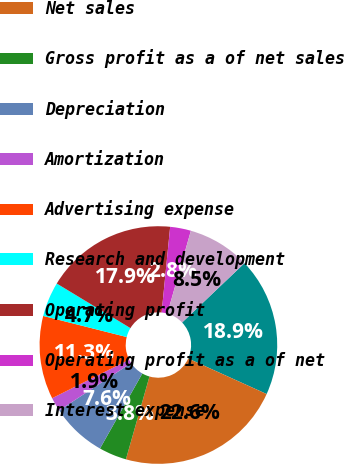Convert chart. <chart><loc_0><loc_0><loc_500><loc_500><pie_chart><fcel>(in millions except per share<fcel>Net sales<fcel>Gross profit as a of net sales<fcel>Depreciation<fcel>Amortization<fcel>Advertising expense<fcel>Research and development<fcel>Operating profit<fcel>Operating profit as a of net<fcel>Interest expense<nl><fcel>18.87%<fcel>22.64%<fcel>3.77%<fcel>7.55%<fcel>1.89%<fcel>11.32%<fcel>4.72%<fcel>17.92%<fcel>2.83%<fcel>8.49%<nl></chart> 